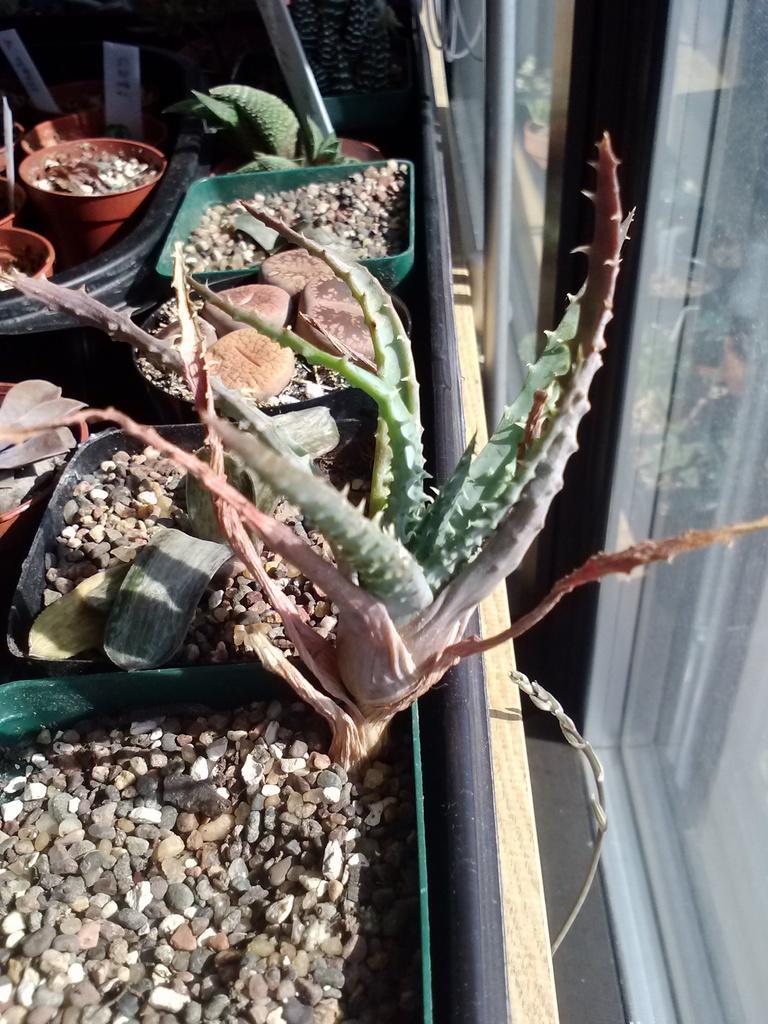In one or two sentences, can you explain what this image depicts? In this picture I can see plants, stones and boards in the pots. 